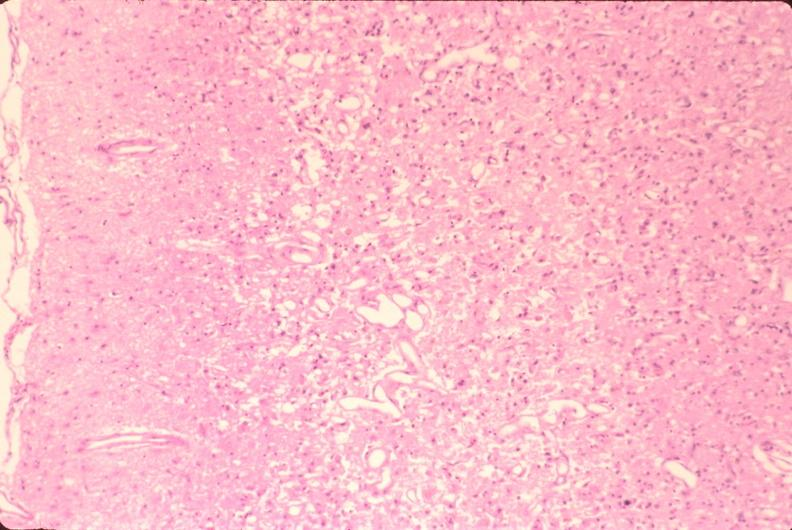does this image show brain, old infarcts, embolic?
Answer the question using a single word or phrase. Yes 